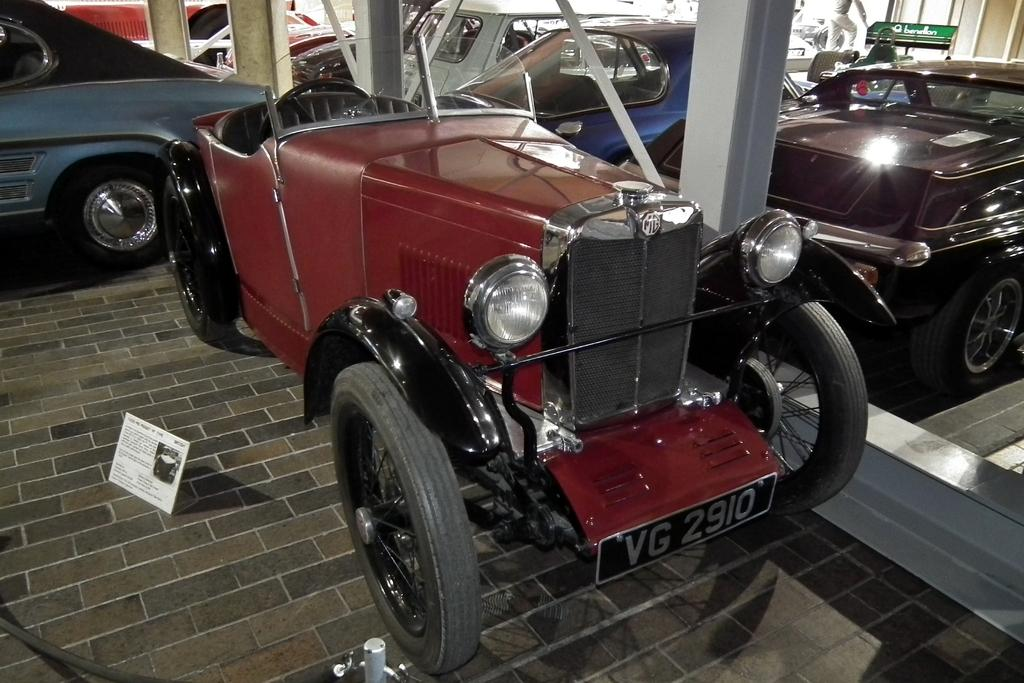Provide a one-sentence caption for the provided image. A vintage car has license plate numbers VG 2910. 